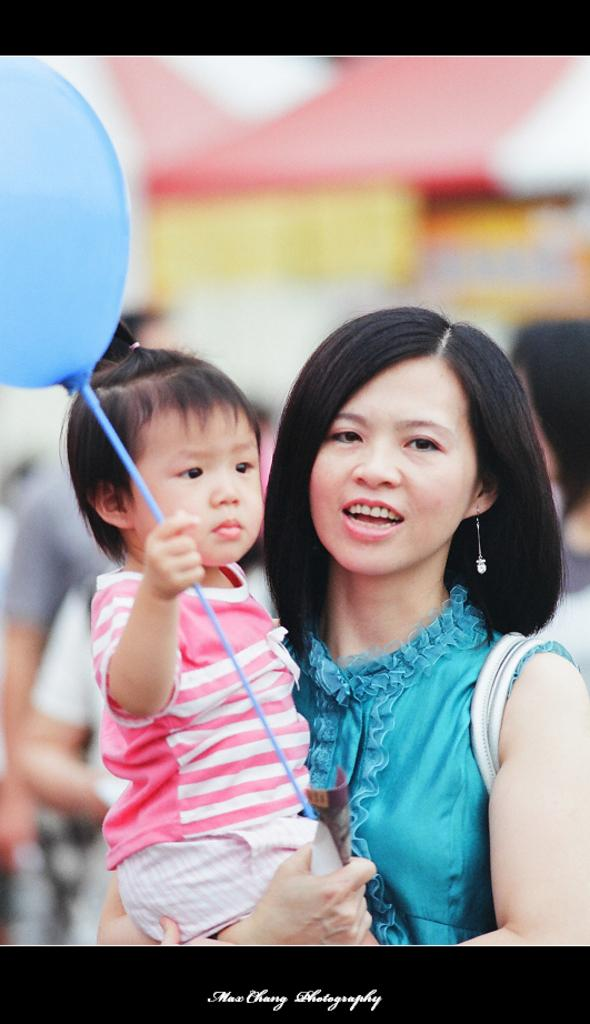Who is the main subject in the image? There is a woman in the image. What is the woman wearing? The woman is wearing a blue dress. What is the woman holding in the image? The woman is holding a baby. What is the baby holding? The baby is holding a balloon. Can you describe the background of the image? The background of the image is blurred. What is present at the bottom of the image? There is text at the bottom of the image. Is it raining in the image? There is no indication of rain in the image. What type of garden can be seen in the image? There is no garden present in the image. 